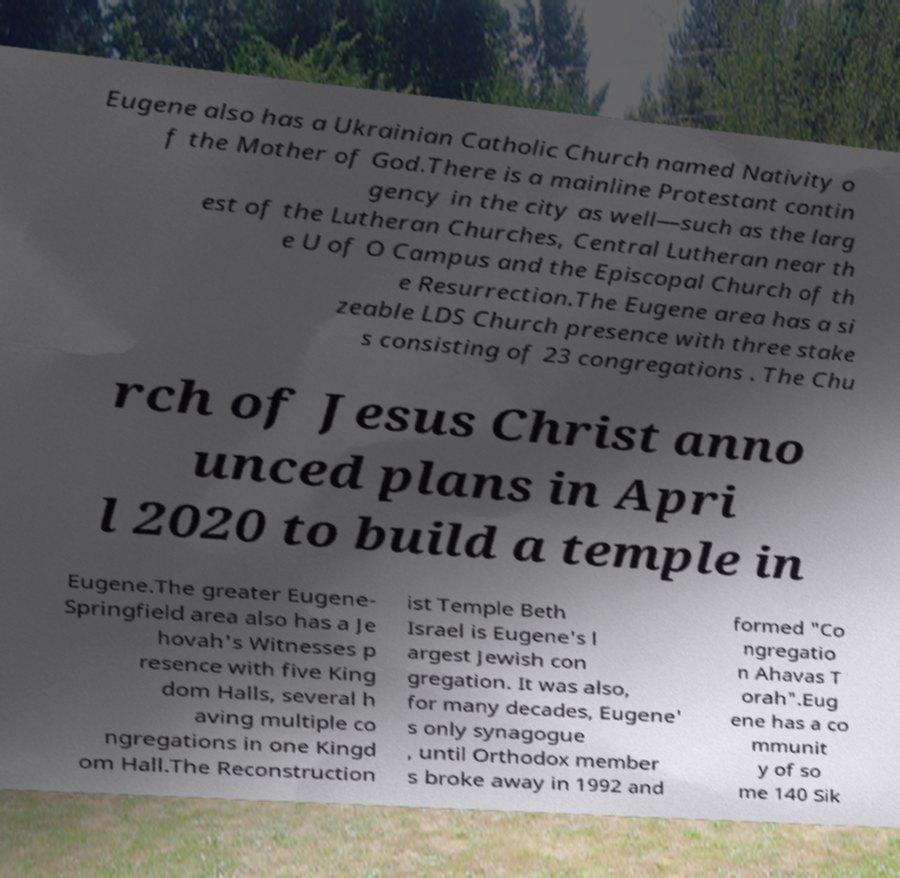I need the written content from this picture converted into text. Can you do that? Eugene also has a Ukrainian Catholic Church named Nativity o f the Mother of God.There is a mainline Protestant contin gency in the city as well—such as the larg est of the Lutheran Churches, Central Lutheran near th e U of O Campus and the Episcopal Church of th e Resurrection.The Eugene area has a si zeable LDS Church presence with three stake s consisting of 23 congregations . The Chu rch of Jesus Christ anno unced plans in Apri l 2020 to build a temple in Eugene.The greater Eugene- Springfield area also has a Je hovah's Witnesses p resence with five King dom Halls, several h aving multiple co ngregations in one Kingd om Hall.The Reconstruction ist Temple Beth Israel is Eugene's l argest Jewish con gregation. It was also, for many decades, Eugene' s only synagogue , until Orthodox member s broke away in 1992 and formed "Co ngregatio n Ahavas T orah".Eug ene has a co mmunit y of so me 140 Sik 